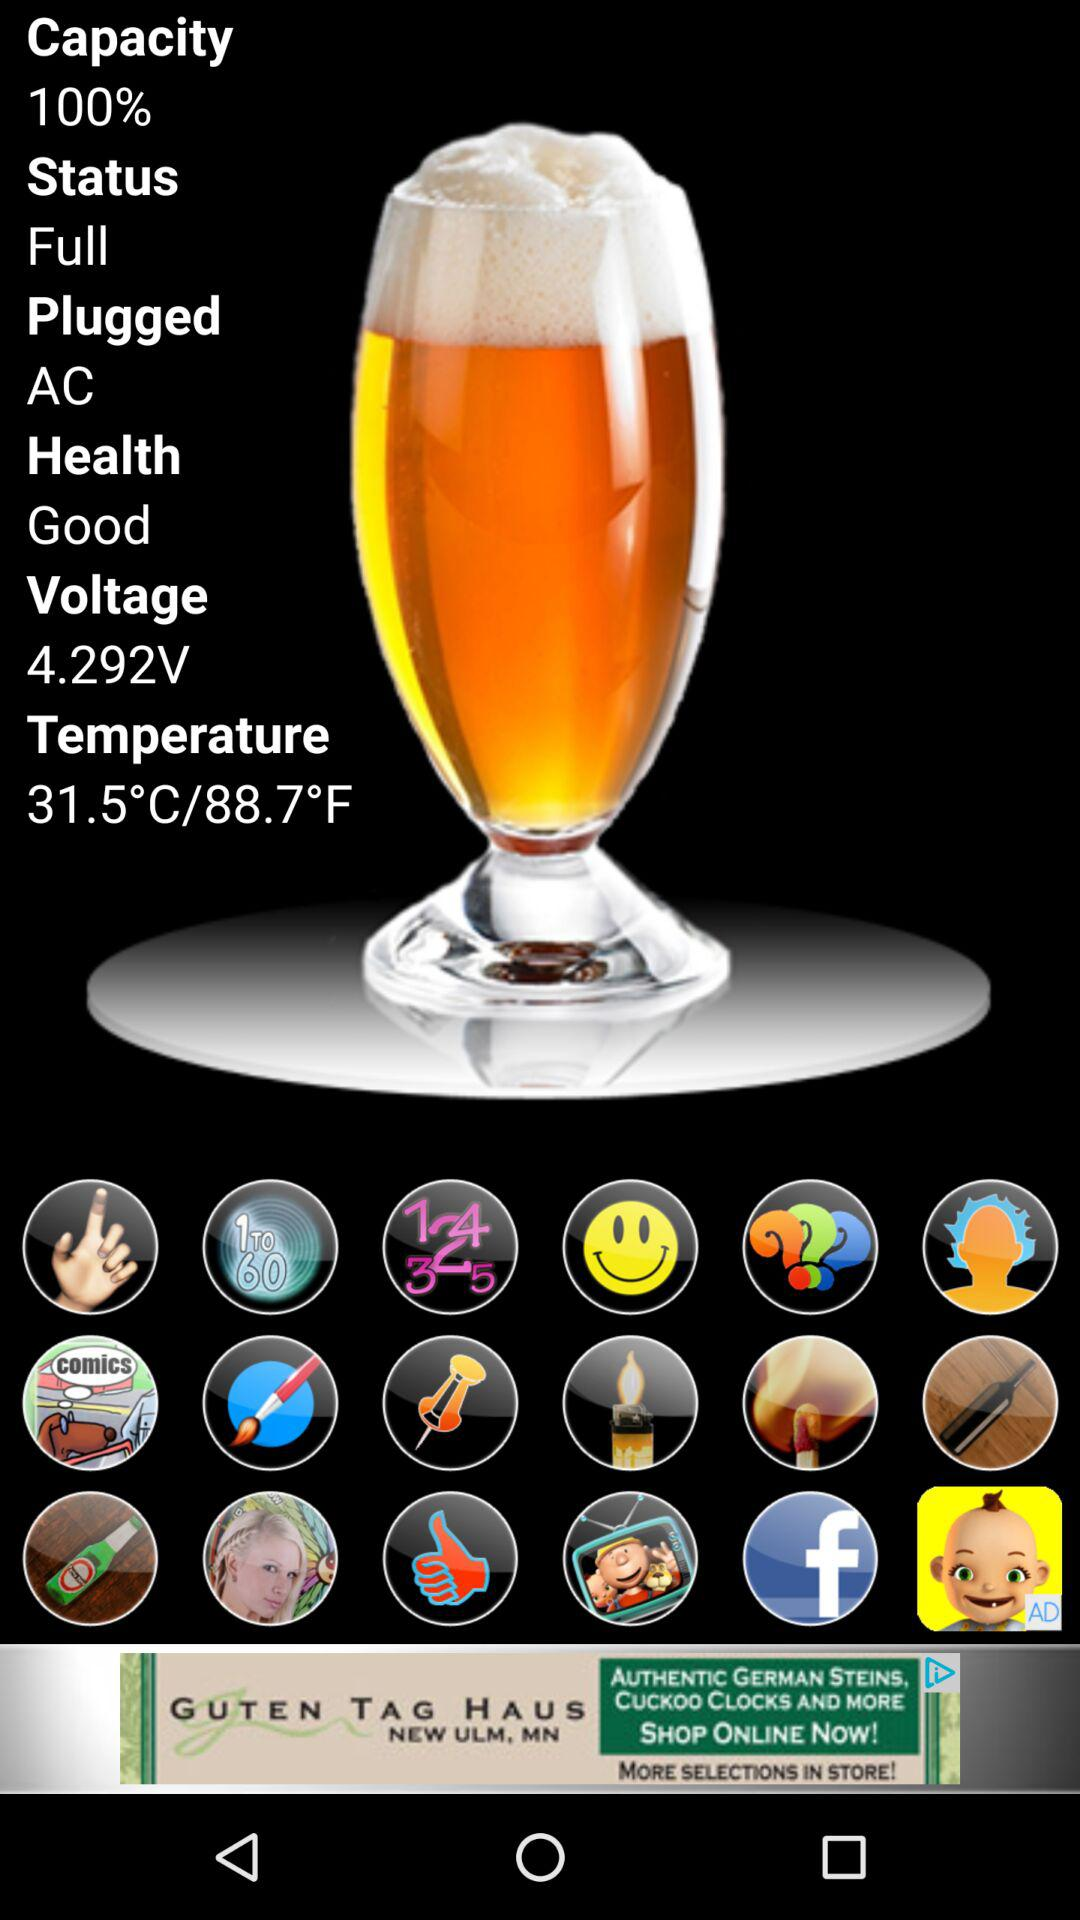What is the capacity? The capacity is 100%. 